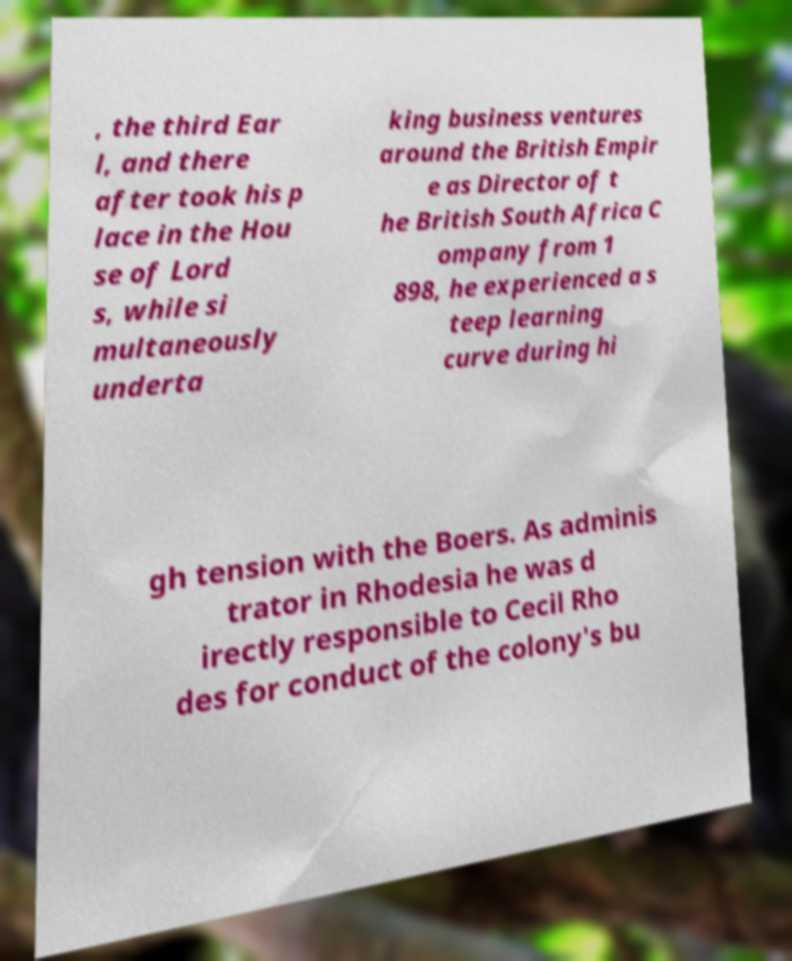I need the written content from this picture converted into text. Can you do that? , the third Ear l, and there after took his p lace in the Hou se of Lord s, while si multaneously underta king business ventures around the British Empir e as Director of t he British South Africa C ompany from 1 898, he experienced a s teep learning curve during hi gh tension with the Boers. As adminis trator in Rhodesia he was d irectly responsible to Cecil Rho des for conduct of the colony's bu 